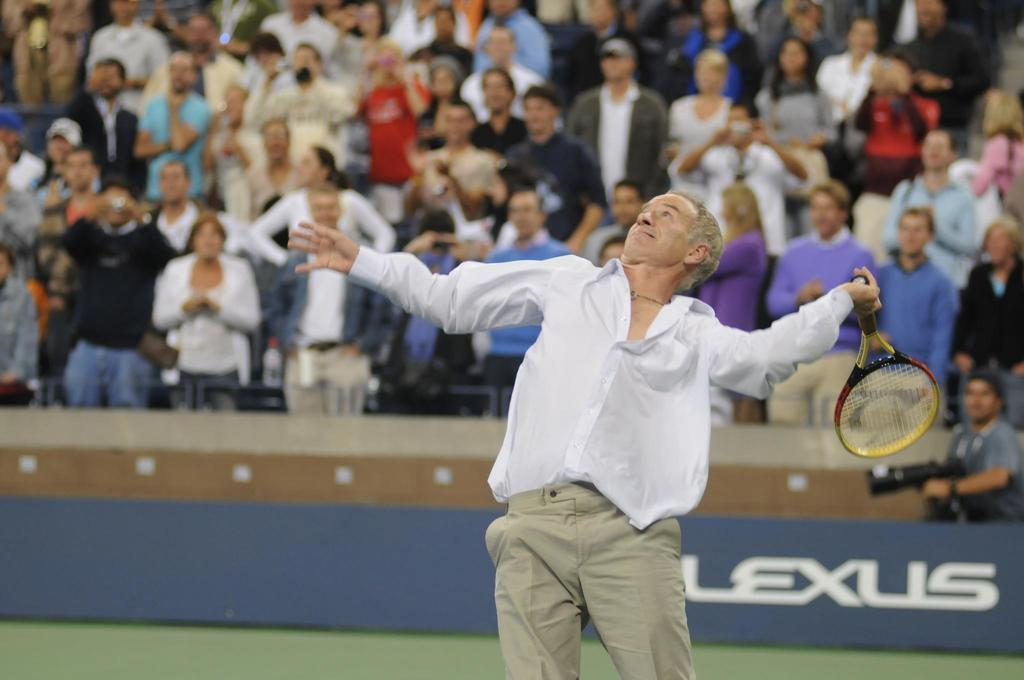Who is the main subject in the image? There is a man in the image. What is the man holding in the image? The man is holding a racket. Can you describe the background of the image? There are people in the background of the image. What color is the man's nose in the image? The image does not provide information about the color of the man's nose, as it focuses on the man holding a racket and the people in the background. 